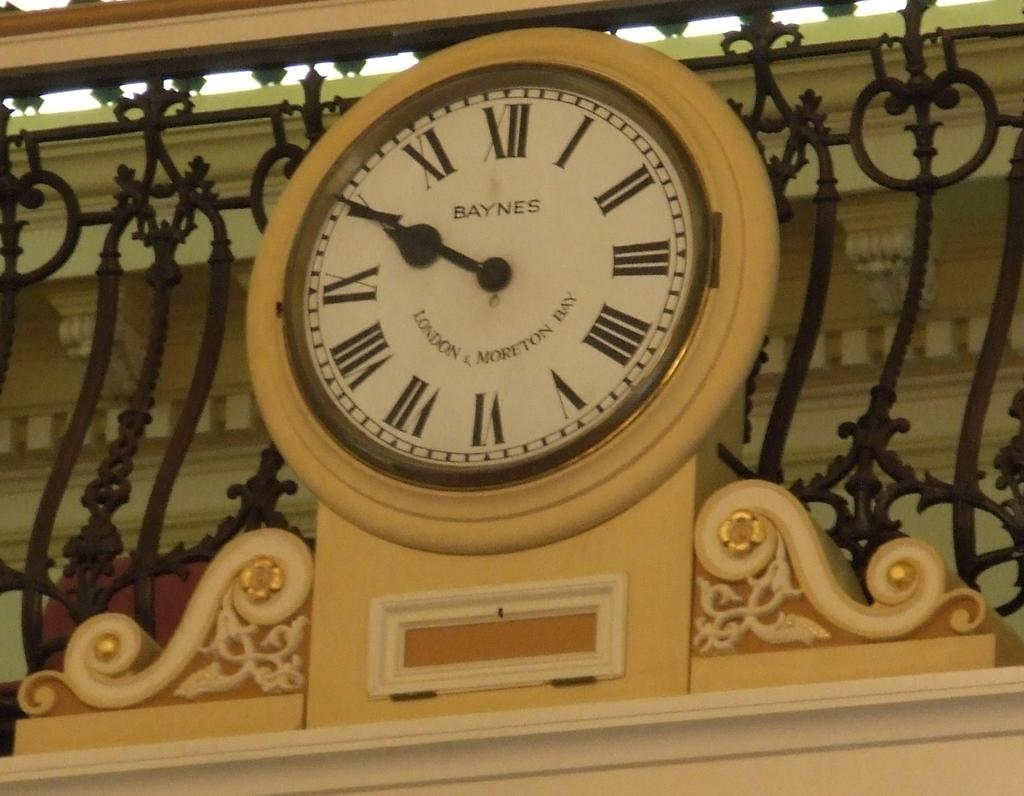<image>
Describe the image concisely. A round clock face that says Baynes on it. 